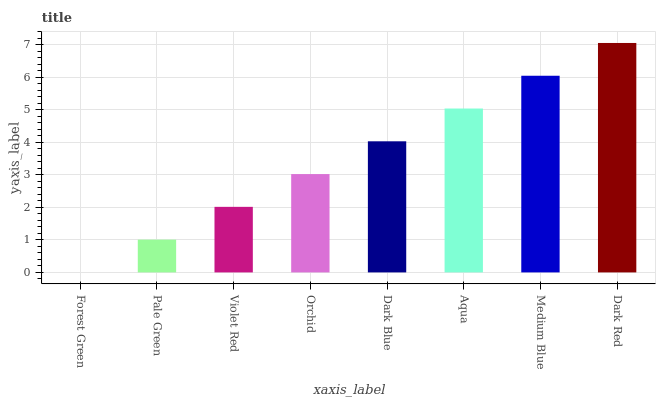Is Pale Green the minimum?
Answer yes or no. No. Is Pale Green the maximum?
Answer yes or no. No. Is Pale Green greater than Forest Green?
Answer yes or no. Yes. Is Forest Green less than Pale Green?
Answer yes or no. Yes. Is Forest Green greater than Pale Green?
Answer yes or no. No. Is Pale Green less than Forest Green?
Answer yes or no. No. Is Dark Blue the high median?
Answer yes or no. Yes. Is Orchid the low median?
Answer yes or no. Yes. Is Medium Blue the high median?
Answer yes or no. No. Is Medium Blue the low median?
Answer yes or no. No. 